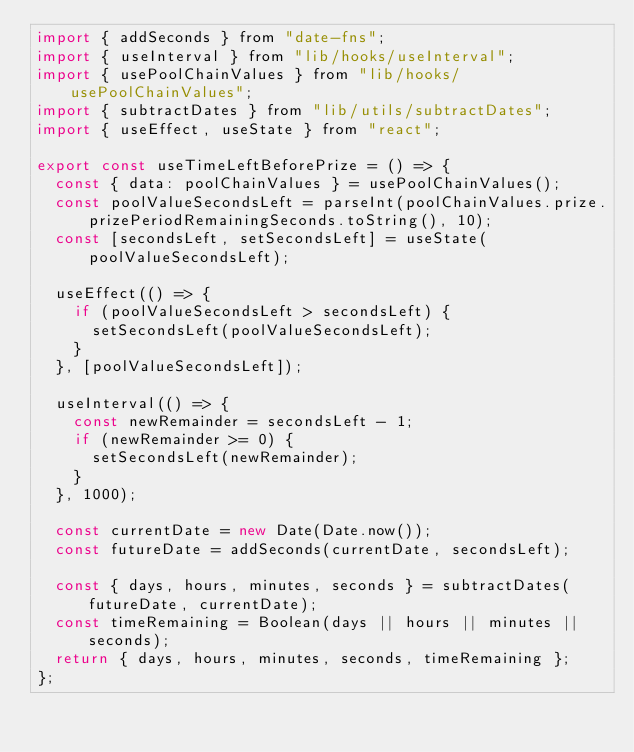Convert code to text. <code><loc_0><loc_0><loc_500><loc_500><_JavaScript_>import { addSeconds } from "date-fns";
import { useInterval } from "lib/hooks/useInterval";
import { usePoolChainValues } from "lib/hooks/usePoolChainValues";
import { subtractDates } from "lib/utils/subtractDates";
import { useEffect, useState } from "react";

export const useTimeLeftBeforePrize = () => {
  const { data: poolChainValues } = usePoolChainValues();
  const poolValueSecondsLeft = parseInt(poolChainValues.prize.prizePeriodRemainingSeconds.toString(), 10);
  const [secondsLeft, setSecondsLeft] = useState(poolValueSecondsLeft);

  useEffect(() => {
    if (poolValueSecondsLeft > secondsLeft) {
      setSecondsLeft(poolValueSecondsLeft);
    }
  }, [poolValueSecondsLeft]);

  useInterval(() => {
    const newRemainder = secondsLeft - 1;
    if (newRemainder >= 0) {
      setSecondsLeft(newRemainder);
    }
  }, 1000);

  const currentDate = new Date(Date.now());
  const futureDate = addSeconds(currentDate, secondsLeft);

  const { days, hours, minutes, seconds } = subtractDates(futureDate, currentDate);
  const timeRemaining = Boolean(days || hours || minutes || seconds);
  return { days, hours, minutes, seconds, timeRemaining };
};
</code> 